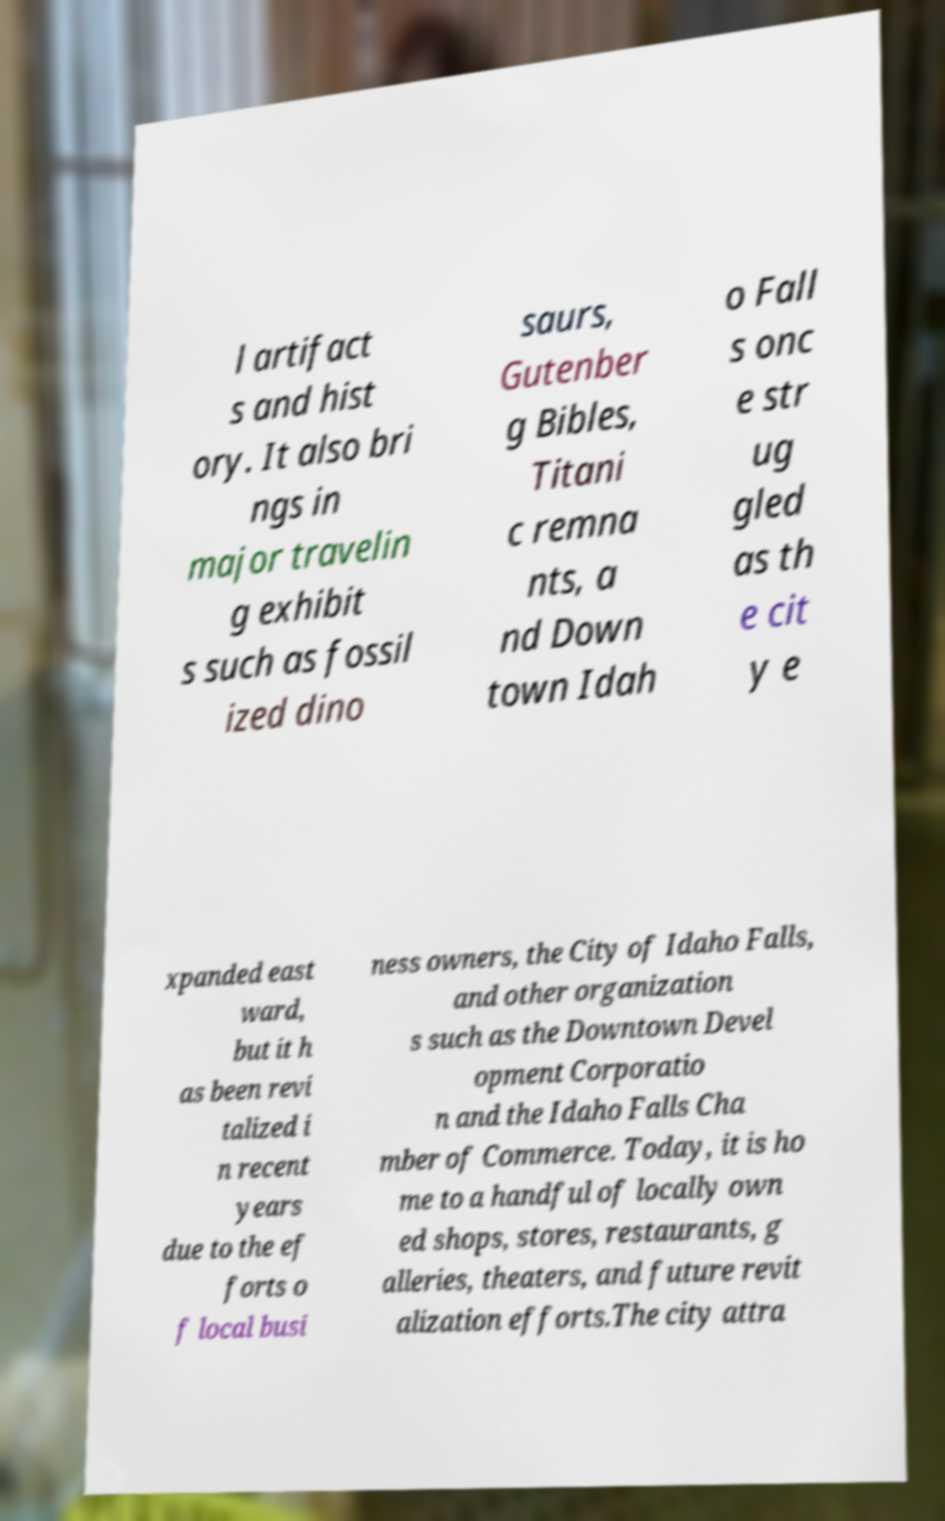Please identify and transcribe the text found in this image. l artifact s and hist ory. It also bri ngs in major travelin g exhibit s such as fossil ized dino saurs, Gutenber g Bibles, Titani c remna nts, a nd Down town Idah o Fall s onc e str ug gled as th e cit y e xpanded east ward, but it h as been revi talized i n recent years due to the ef forts o f local busi ness owners, the City of Idaho Falls, and other organization s such as the Downtown Devel opment Corporatio n and the Idaho Falls Cha mber of Commerce. Today, it is ho me to a handful of locally own ed shops, stores, restaurants, g alleries, theaters, and future revit alization efforts.The city attra 